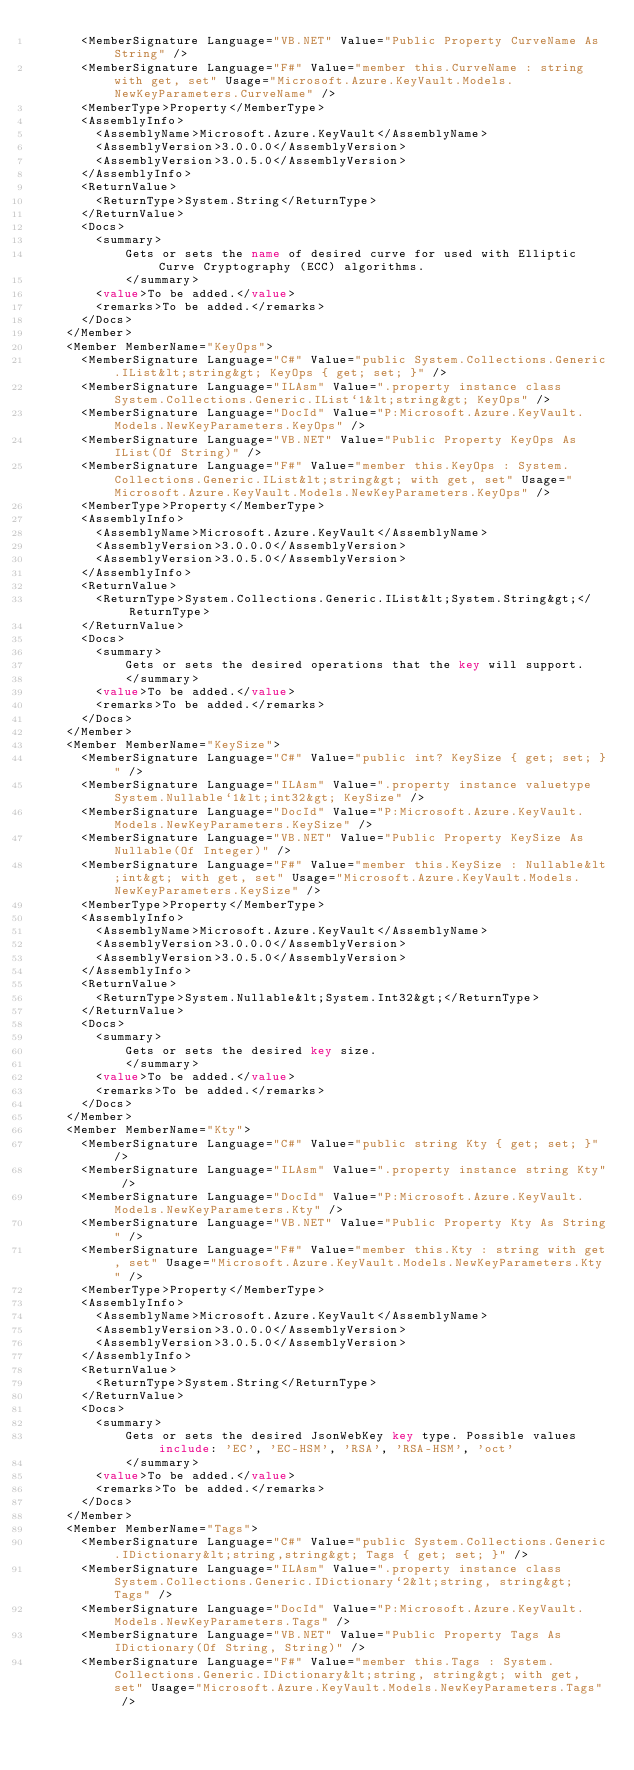Convert code to text. <code><loc_0><loc_0><loc_500><loc_500><_XML_>      <MemberSignature Language="VB.NET" Value="Public Property CurveName As String" />
      <MemberSignature Language="F#" Value="member this.CurveName : string with get, set" Usage="Microsoft.Azure.KeyVault.Models.NewKeyParameters.CurveName" />
      <MemberType>Property</MemberType>
      <AssemblyInfo>
        <AssemblyName>Microsoft.Azure.KeyVault</AssemblyName>
        <AssemblyVersion>3.0.0.0</AssemblyVersion>
        <AssemblyVersion>3.0.5.0</AssemblyVersion>
      </AssemblyInfo>
      <ReturnValue>
        <ReturnType>System.String</ReturnType>
      </ReturnValue>
      <Docs>
        <summary>
            Gets or sets the name of desired curve for used with Elliptic Curve Cryptography (ECC) algorithms.
            </summary>
        <value>To be added.</value>
        <remarks>To be added.</remarks>
      </Docs>
    </Member>
    <Member MemberName="KeyOps">
      <MemberSignature Language="C#" Value="public System.Collections.Generic.IList&lt;string&gt; KeyOps { get; set; }" />
      <MemberSignature Language="ILAsm" Value=".property instance class System.Collections.Generic.IList`1&lt;string&gt; KeyOps" />
      <MemberSignature Language="DocId" Value="P:Microsoft.Azure.KeyVault.Models.NewKeyParameters.KeyOps" />
      <MemberSignature Language="VB.NET" Value="Public Property KeyOps As IList(Of String)" />
      <MemberSignature Language="F#" Value="member this.KeyOps : System.Collections.Generic.IList&lt;string&gt; with get, set" Usage="Microsoft.Azure.KeyVault.Models.NewKeyParameters.KeyOps" />
      <MemberType>Property</MemberType>
      <AssemblyInfo>
        <AssemblyName>Microsoft.Azure.KeyVault</AssemblyName>
        <AssemblyVersion>3.0.0.0</AssemblyVersion>
        <AssemblyVersion>3.0.5.0</AssemblyVersion>
      </AssemblyInfo>
      <ReturnValue>
        <ReturnType>System.Collections.Generic.IList&lt;System.String&gt;</ReturnType>
      </ReturnValue>
      <Docs>
        <summary>
            Gets or sets the desired operations that the key will support.
            </summary>
        <value>To be added.</value>
        <remarks>To be added.</remarks>
      </Docs>
    </Member>
    <Member MemberName="KeySize">
      <MemberSignature Language="C#" Value="public int? KeySize { get; set; }" />
      <MemberSignature Language="ILAsm" Value=".property instance valuetype System.Nullable`1&lt;int32&gt; KeySize" />
      <MemberSignature Language="DocId" Value="P:Microsoft.Azure.KeyVault.Models.NewKeyParameters.KeySize" />
      <MemberSignature Language="VB.NET" Value="Public Property KeySize As Nullable(Of Integer)" />
      <MemberSignature Language="F#" Value="member this.KeySize : Nullable&lt;int&gt; with get, set" Usage="Microsoft.Azure.KeyVault.Models.NewKeyParameters.KeySize" />
      <MemberType>Property</MemberType>
      <AssemblyInfo>
        <AssemblyName>Microsoft.Azure.KeyVault</AssemblyName>
        <AssemblyVersion>3.0.0.0</AssemblyVersion>
        <AssemblyVersion>3.0.5.0</AssemblyVersion>
      </AssemblyInfo>
      <ReturnValue>
        <ReturnType>System.Nullable&lt;System.Int32&gt;</ReturnType>
      </ReturnValue>
      <Docs>
        <summary>
            Gets or sets the desired key size.
            </summary>
        <value>To be added.</value>
        <remarks>To be added.</remarks>
      </Docs>
    </Member>
    <Member MemberName="Kty">
      <MemberSignature Language="C#" Value="public string Kty { get; set; }" />
      <MemberSignature Language="ILAsm" Value=".property instance string Kty" />
      <MemberSignature Language="DocId" Value="P:Microsoft.Azure.KeyVault.Models.NewKeyParameters.Kty" />
      <MemberSignature Language="VB.NET" Value="Public Property Kty As String" />
      <MemberSignature Language="F#" Value="member this.Kty : string with get, set" Usage="Microsoft.Azure.KeyVault.Models.NewKeyParameters.Kty" />
      <MemberType>Property</MemberType>
      <AssemblyInfo>
        <AssemblyName>Microsoft.Azure.KeyVault</AssemblyName>
        <AssemblyVersion>3.0.0.0</AssemblyVersion>
        <AssemblyVersion>3.0.5.0</AssemblyVersion>
      </AssemblyInfo>
      <ReturnValue>
        <ReturnType>System.String</ReturnType>
      </ReturnValue>
      <Docs>
        <summary>
            Gets or sets the desired JsonWebKey key type. Possible values include: 'EC', 'EC-HSM', 'RSA', 'RSA-HSM', 'oct'
            </summary>
        <value>To be added.</value>
        <remarks>To be added.</remarks>
      </Docs>
    </Member>
    <Member MemberName="Tags">
      <MemberSignature Language="C#" Value="public System.Collections.Generic.IDictionary&lt;string,string&gt; Tags { get; set; }" />
      <MemberSignature Language="ILAsm" Value=".property instance class System.Collections.Generic.IDictionary`2&lt;string, string&gt; Tags" />
      <MemberSignature Language="DocId" Value="P:Microsoft.Azure.KeyVault.Models.NewKeyParameters.Tags" />
      <MemberSignature Language="VB.NET" Value="Public Property Tags As IDictionary(Of String, String)" />
      <MemberSignature Language="F#" Value="member this.Tags : System.Collections.Generic.IDictionary&lt;string, string&gt; with get, set" Usage="Microsoft.Azure.KeyVault.Models.NewKeyParameters.Tags" /></code> 